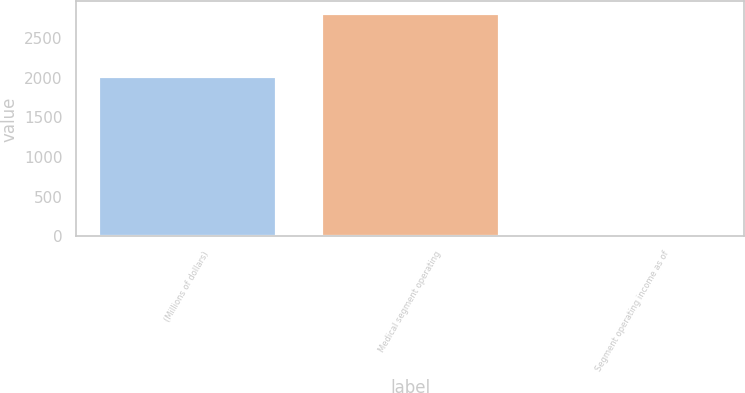Convert chart. <chart><loc_0><loc_0><loc_500><loc_500><bar_chart><fcel>(Millions of dollars)<fcel>Medical segment operating<fcel>Segment operating income as of<nl><fcel>2019<fcel>2824<fcel>31.2<nl></chart> 